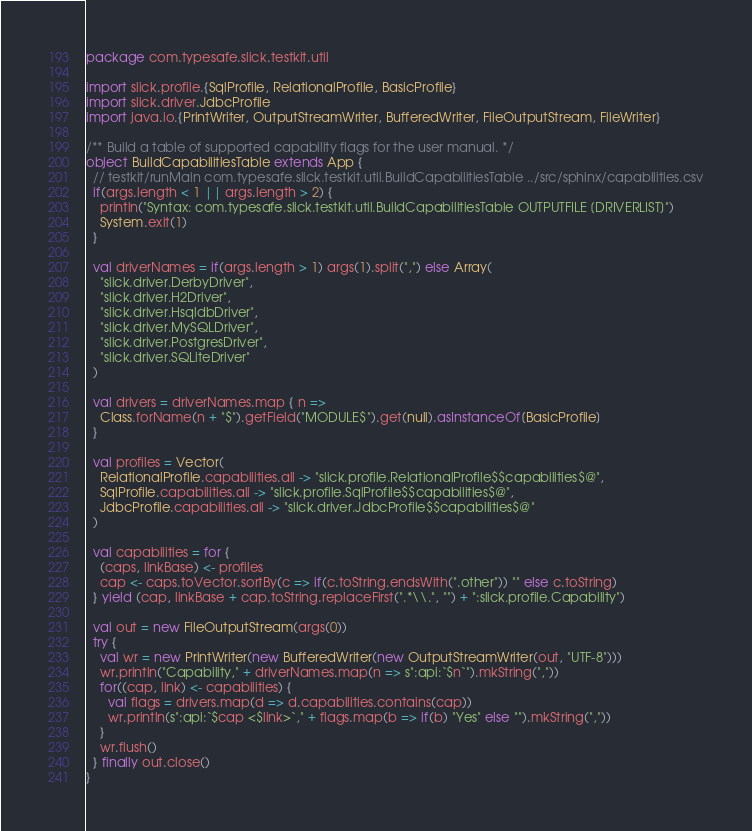<code> <loc_0><loc_0><loc_500><loc_500><_Scala_>package com.typesafe.slick.testkit.util

import slick.profile.{SqlProfile, RelationalProfile, BasicProfile}
import slick.driver.JdbcProfile
import java.io.{PrintWriter, OutputStreamWriter, BufferedWriter, FileOutputStream, FileWriter}

/** Build a table of supported capability flags for the user manual. */
object BuildCapabilitiesTable extends App {
  // testkit/runMain com.typesafe.slick.testkit.util.BuildCapabilitiesTable ../src/sphinx/capabilities.csv
  if(args.length < 1 || args.length > 2) {
    println("Syntax: com.typesafe.slick.testkit.util.BuildCapabilitiesTable OUTPUTFILE [DRIVERLIST]")
    System.exit(1)
  }

  val driverNames = if(args.length > 1) args(1).split(",") else Array(
    "slick.driver.DerbyDriver",
    "slick.driver.H2Driver",
    "slick.driver.HsqldbDriver",
    "slick.driver.MySQLDriver",
    "slick.driver.PostgresDriver",
    "slick.driver.SQLiteDriver"
  )

  val drivers = driverNames.map { n =>
    Class.forName(n + "$").getField("MODULE$").get(null).asInstanceOf[BasicProfile]
  }

  val profiles = Vector(
    RelationalProfile.capabilities.all -> "slick.profile.RelationalProfile$$capabilities$@",
    SqlProfile.capabilities.all -> "slick.profile.SqlProfile$$capabilities$@",
    JdbcProfile.capabilities.all -> "slick.driver.JdbcProfile$$capabilities$@"
  )

  val capabilities = for {
    (caps, linkBase) <- profiles
    cap <- caps.toVector.sortBy(c => if(c.toString.endsWith(".other")) "" else c.toString)
  } yield (cap, linkBase + cap.toString.replaceFirst(".*\\.", "") + ":slick.profile.Capability")

  val out = new FileOutputStream(args(0))
  try {
    val wr = new PrintWriter(new BufferedWriter(new OutputStreamWriter(out, "UTF-8")))
    wr.println("Capability," + driverNames.map(n => s":api:`$n`").mkString(","))
    for((cap, link) <- capabilities) {
      val flags = drivers.map(d => d.capabilities.contains(cap))
      wr.println(s":api:`$cap <$link>`," + flags.map(b => if(b) "Yes" else "").mkString(","))
    }
    wr.flush()
  } finally out.close()
}
</code> 